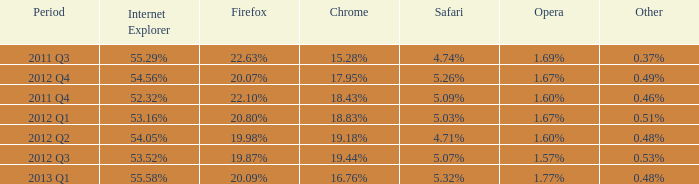What safari has 2012 q4 as the period? 5.26%. 